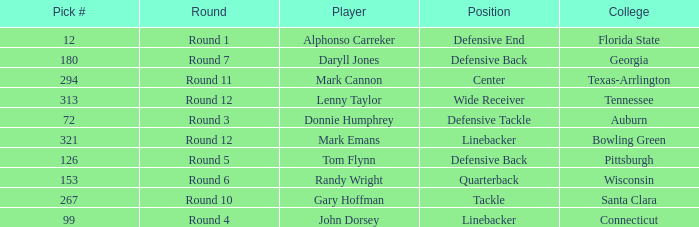What is Mark Cannon's College? Texas-Arrlington. 